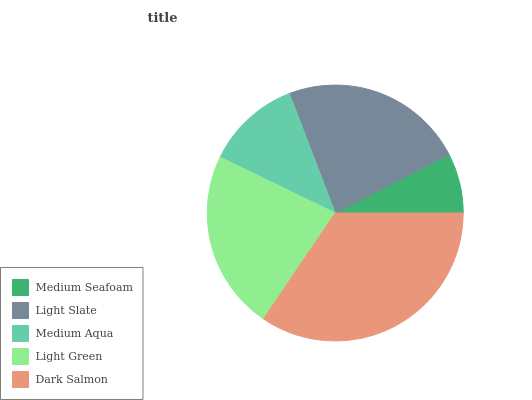Is Medium Seafoam the minimum?
Answer yes or no. Yes. Is Dark Salmon the maximum?
Answer yes or no. Yes. Is Light Slate the minimum?
Answer yes or no. No. Is Light Slate the maximum?
Answer yes or no. No. Is Light Slate greater than Medium Seafoam?
Answer yes or no. Yes. Is Medium Seafoam less than Light Slate?
Answer yes or no. Yes. Is Medium Seafoam greater than Light Slate?
Answer yes or no. No. Is Light Slate less than Medium Seafoam?
Answer yes or no. No. Is Light Green the high median?
Answer yes or no. Yes. Is Light Green the low median?
Answer yes or no. Yes. Is Medium Seafoam the high median?
Answer yes or no. No. Is Dark Salmon the low median?
Answer yes or no. No. 